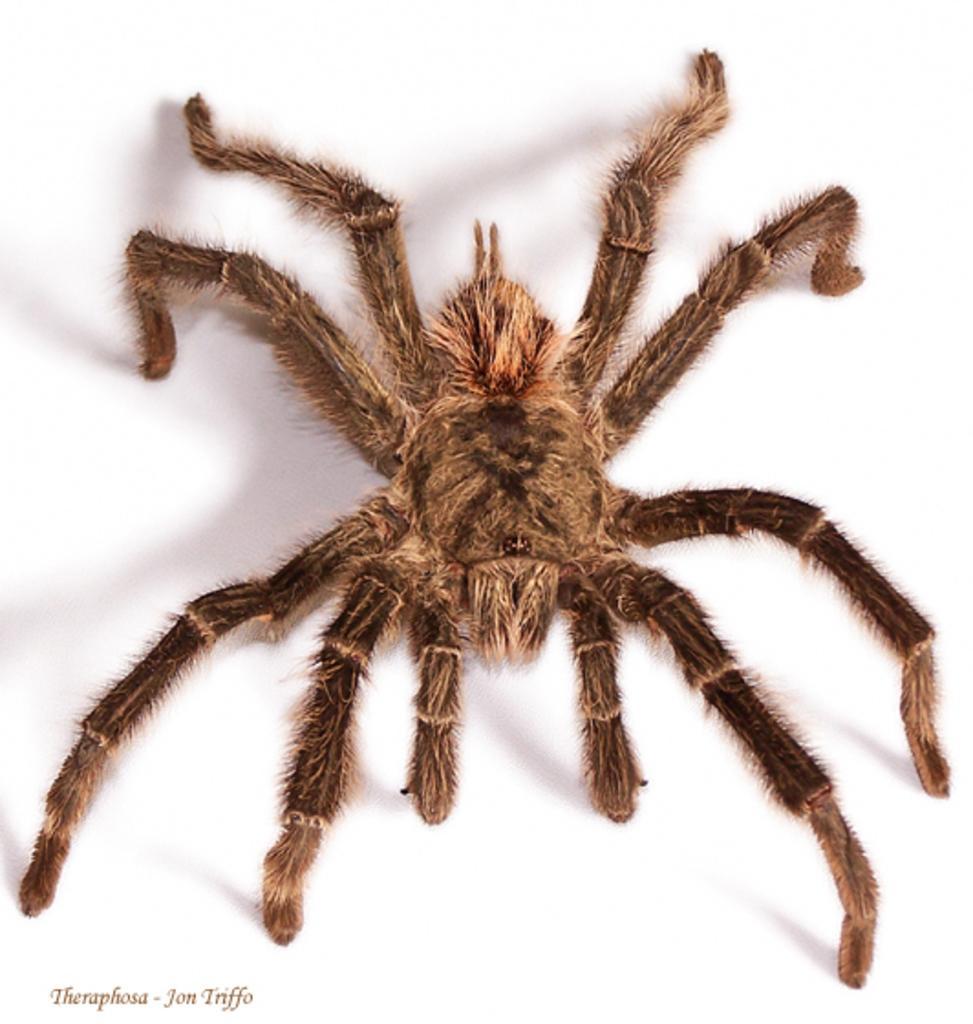Describe this image in one or two sentences. In this image we can see one spider, some text on the bottom left side of the image and there is a white background. 